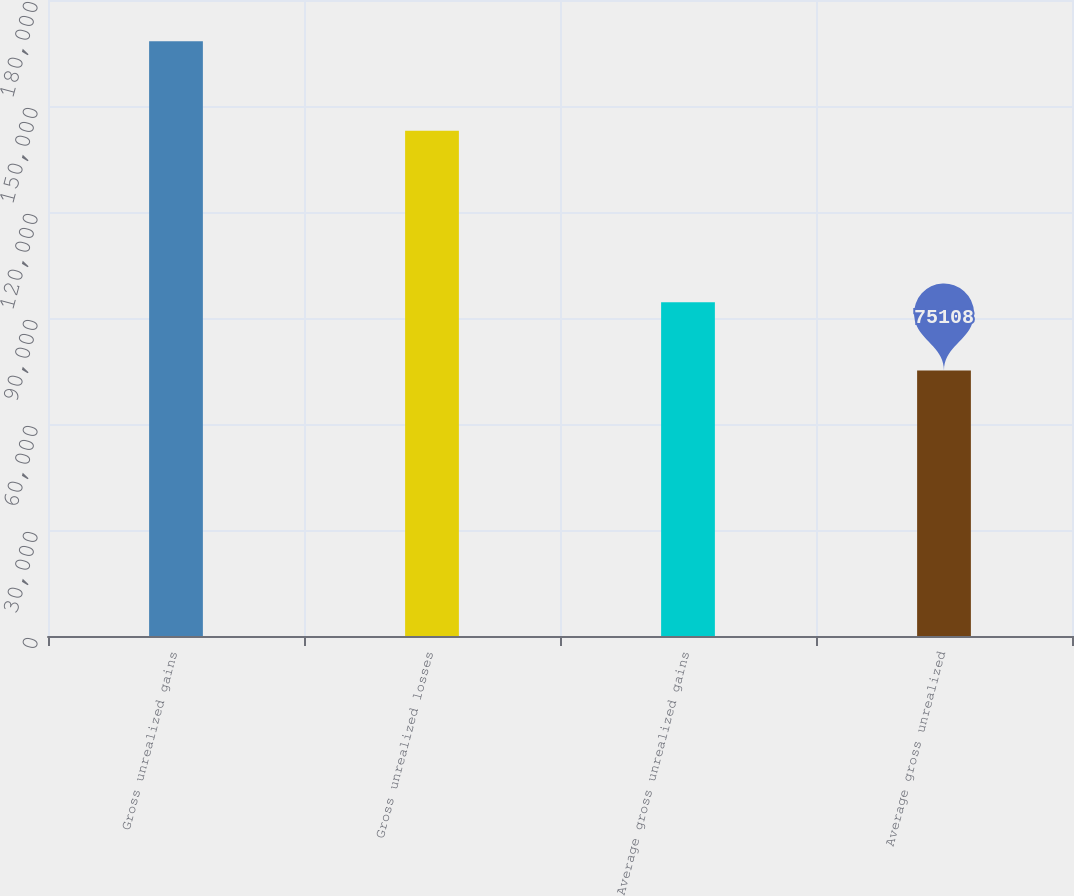Convert chart to OTSL. <chart><loc_0><loc_0><loc_500><loc_500><bar_chart><fcel>Gross unrealized gains<fcel>Gross unrealized losses<fcel>Average gross unrealized gains<fcel>Average gross unrealized<nl><fcel>168317<fcel>143025<fcel>94475<fcel>75108<nl></chart> 